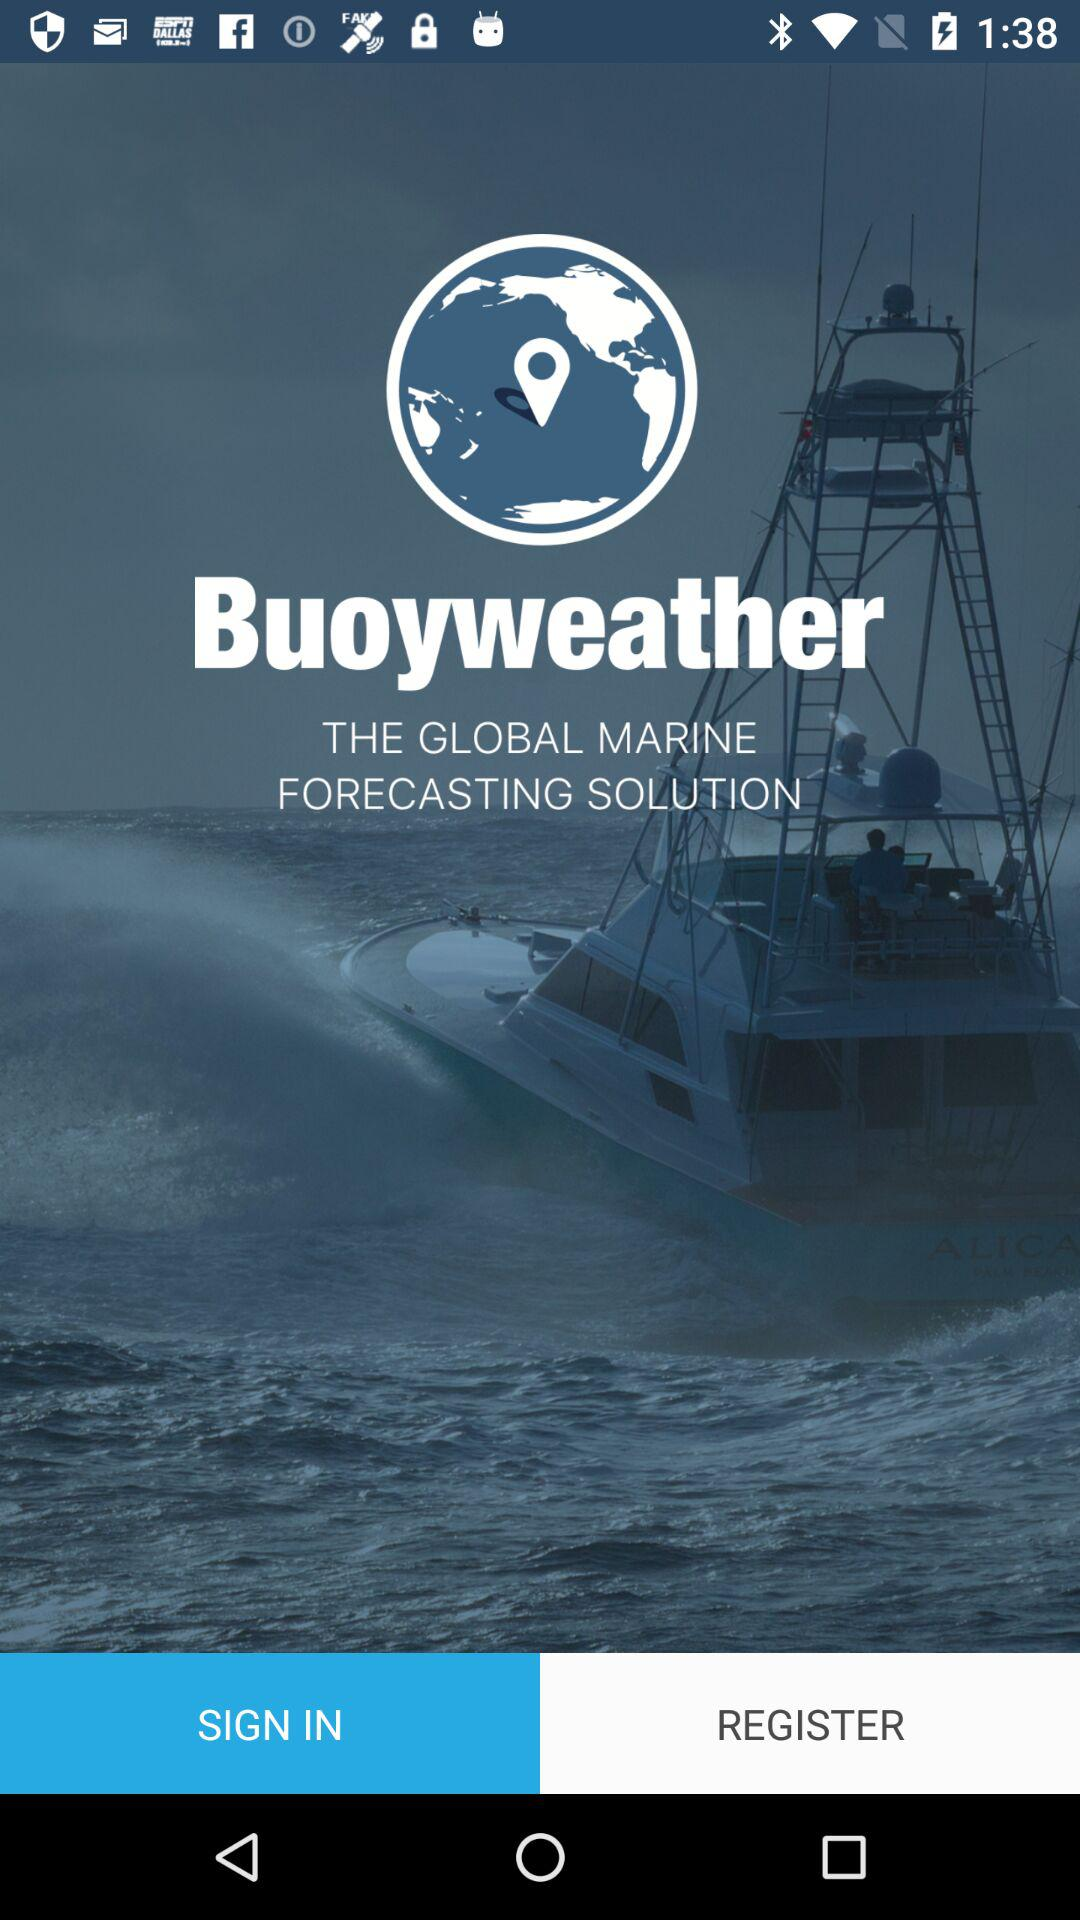Who is the user?
When the provided information is insufficient, respond with <no answer>. <no answer> 